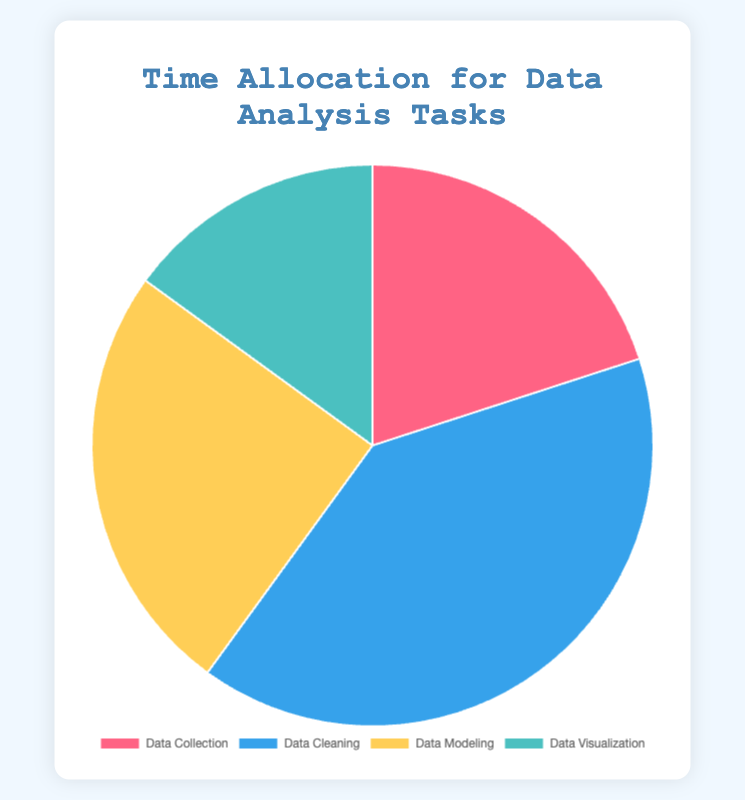What task takes up the most time in data analysis? By examining the pie chart, we identify that the section labeled "Data Cleaning" occupies the largest portion.
Answer: Data Cleaning Which task takes the least amount of time? The pie chart shows that "Data Visualization" has the smallest section, indicating it takes the least amount of time.
Answer: Data Visualization How much more time is spent on Data Cleaning compared to Data Modeling? Data Cleaning takes 40% while Data Modeling takes 25%. The difference can be calculated as 40% - 25%.
Answer: 15% What is the combined percentage of time spent on Data Collection and Data Visualization? Data Collection is 20% and Data Visualization is 15%. Adding them together gives 20% + 15%.
Answer: 35% Is more time spent on Data Modeling or Data Collection? From the pie chart, Data Modeling occupies 25% and Data Collection occupies 20%. Since 25% is more than 20%, more time is spent on Data Modeling.
Answer: Data Modeling What percentage of the time is spent on tasks other than Data Cleaning? The total time spent on tasks other than Data Cleaning is the sum of Data Collection (20%), Data Modeling (25%), and Data Visualization (15%). This is 20% + 25% + 15%.
Answer: 60% Which tasks combined take up almost half of the total time? Data Collection (20%) and Data Modeling (25%) together account for 20% + 25%, which is close to half (45%).
Answer: Data Collection and Data Modeling What is the average percentage of time spent on all tasks? Summing up the percentages for all tasks: 20% (Data Collection) + 40% (Data Cleaning) + 25% (Data Modeling) + 15% (Data Visualization) = 100%. Dividing by the number of tasks (4) gives 100%/4.
Answer: 25% How does the time spent on Data Cleaning compare to the average time spent on all tasks? The average time spent on all tasks is 25%. Time spent on Data Cleaning is 40%. 40% is greater than 25%.
Answer: Greater What is the difference in percentage between the task with the lowest and the highest time allocation? The task with the lowest time allocation is Data Visualization (15%), and the highest is Data Cleaning (40%). The difference is 40% - 15%.
Answer: 25% What percentage of the time is spent on tasks that involve data preparation (Data Collection and Data Cleaning)? Data Collection takes 20% and Data Cleaning takes 40%. Adding them gives 20% + 40%.
Answer: 60% 